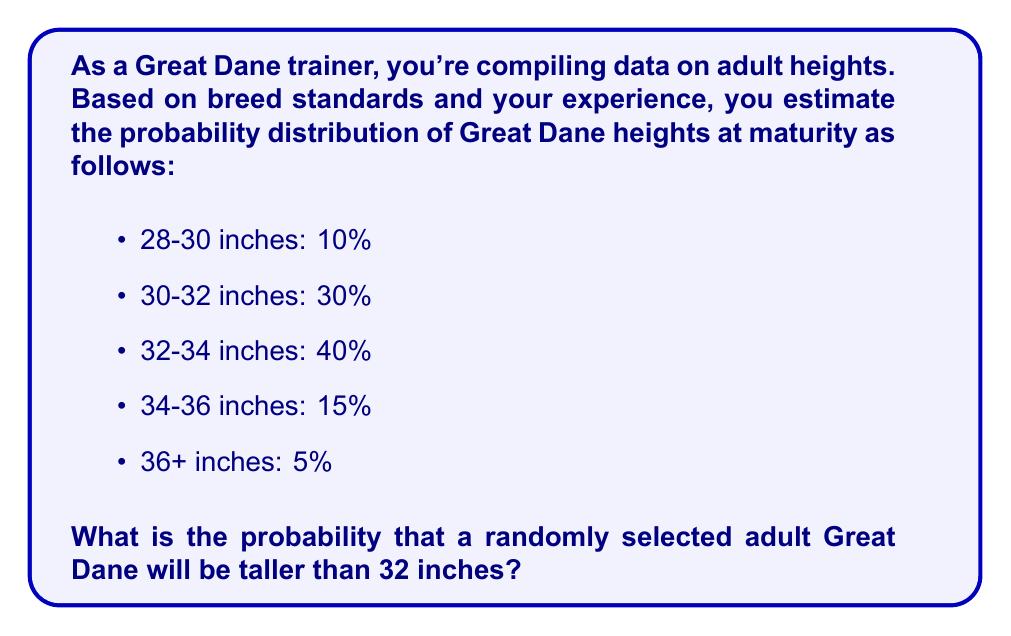Help me with this question. To solve this problem, we need to follow these steps:

1. Identify the height ranges that are taller than 32 inches.
2. Sum the probabilities of these ranges.

Let's break it down:

1. Height ranges taller than 32 inches:
   - 32-34 inches: 40%
   - 34-36 inches: 15%
   - 36+ inches: 5%

2. Sum the probabilities:
   $$ P(\text{height} > 32\text{ inches}) = 40\% + 15\% + 5\% $$
   
   Converting percentages to decimals:
   $$ P(\text{height} > 32\text{ inches}) = 0.40 + 0.15 + 0.05 = 0.60 $$

Therefore, the probability that a randomly selected adult Great Dane will be taller than 32 inches is 0.60 or 60%.
Answer: 0.60 